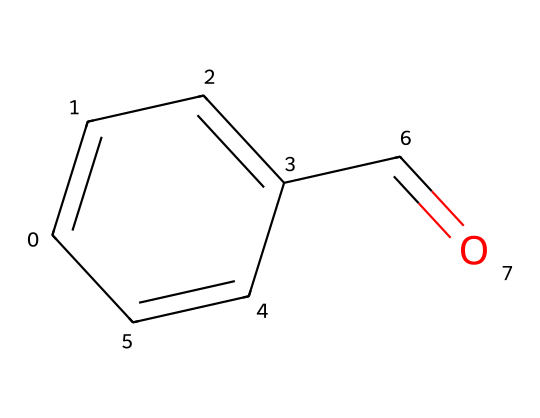What is the molecular formula of benzaldehyde? The SMILES representation indicates the types and numbers of atoms present in the structure. Counting the carbons (C) gives 7, oxygens (O) gives 1, and hydrogens (H) counts to 6. Thus, the molecular formula is C7H6O.
Answer: C7H6O How many pi bonds are present in benzaldehyde? By analyzing the SMILES, we can see that there are two double bonds in the aromatic ring and one double bond in the carbonyl group. Hence, there are three pi bonds total.
Answer: 3 What functional group is indicated by the C=O bond? The presence of the carbon-oxygen double bond (C=O) suggests the presence of a carbonyl group, which is characteristic of aldehydes. This specific configuration qualifies the chemical as an aldehyde.
Answer: carbonyl group How does the presence of the aldehyde functional group impact the aroma of benzaldehyde? The aldehyde functional group, especially in this case, provides a distinctive fragrant and sweet odor, commonly noted in artificial almond flavoring due to its specific molecular structure. This largely contributes to its use as a flavoring agent.
Answer: distinctive fragrant and sweet odor What type of compound is benzaldehyde classified as? Given that benzaldehyde has a carbonyl group and a surrounding aromatic structure, it is classified as an aromatic aldehyde. This places it within the category of aldehydes specifically distinguished by their aromatic rings.
Answer: aromatic aldehyde 